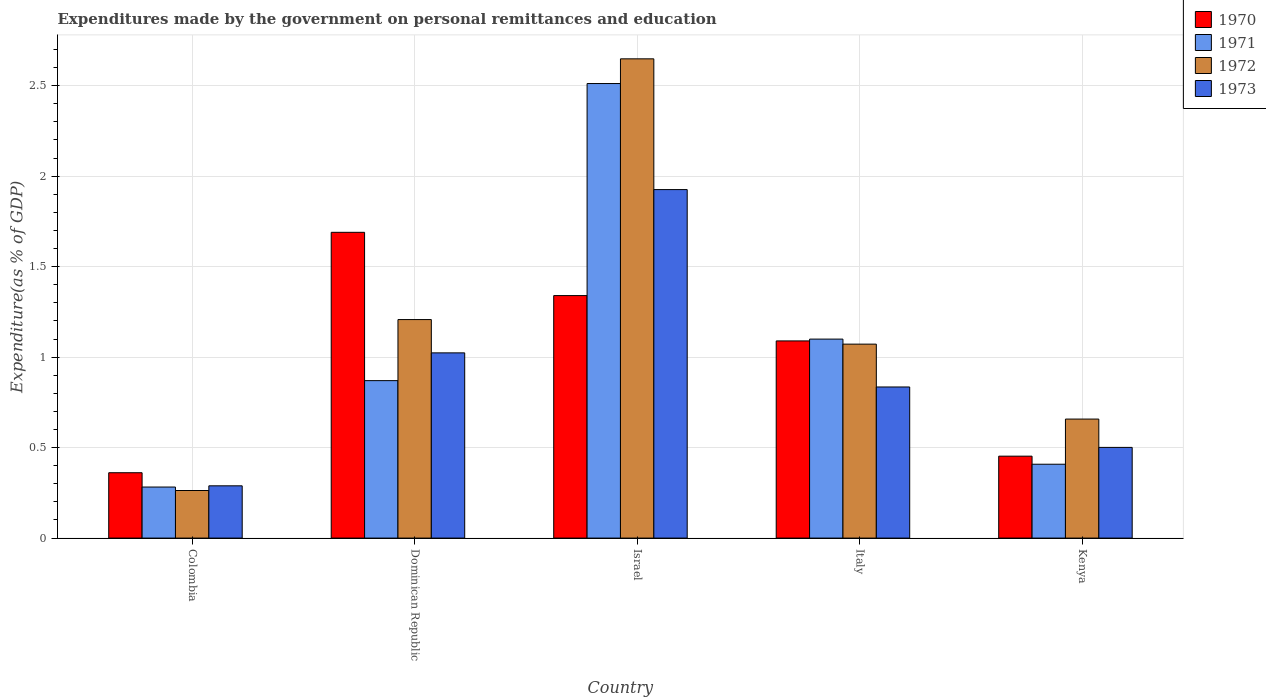How many groups of bars are there?
Offer a very short reply. 5. Are the number of bars on each tick of the X-axis equal?
Offer a terse response. Yes. What is the label of the 2nd group of bars from the left?
Ensure brevity in your answer.  Dominican Republic. What is the expenditures made by the government on personal remittances and education in 1972 in Colombia?
Your answer should be compact. 0.26. Across all countries, what is the maximum expenditures made by the government on personal remittances and education in 1972?
Ensure brevity in your answer.  2.65. Across all countries, what is the minimum expenditures made by the government on personal remittances and education in 1972?
Your answer should be very brief. 0.26. In which country was the expenditures made by the government on personal remittances and education in 1973 maximum?
Ensure brevity in your answer.  Israel. What is the total expenditures made by the government on personal remittances and education in 1970 in the graph?
Your answer should be compact. 4.93. What is the difference between the expenditures made by the government on personal remittances and education in 1973 in Colombia and that in Dominican Republic?
Keep it short and to the point. -0.73. What is the difference between the expenditures made by the government on personal remittances and education in 1972 in Italy and the expenditures made by the government on personal remittances and education in 1970 in Dominican Republic?
Make the answer very short. -0.62. What is the average expenditures made by the government on personal remittances and education in 1970 per country?
Make the answer very short. 0.99. What is the difference between the expenditures made by the government on personal remittances and education of/in 1970 and expenditures made by the government on personal remittances and education of/in 1973 in Italy?
Provide a succinct answer. 0.25. What is the ratio of the expenditures made by the government on personal remittances and education in 1973 in Colombia to that in Kenya?
Offer a terse response. 0.58. Is the expenditures made by the government on personal remittances and education in 1972 in Dominican Republic less than that in Italy?
Give a very brief answer. No. Is the difference between the expenditures made by the government on personal remittances and education in 1970 in Dominican Republic and Italy greater than the difference between the expenditures made by the government on personal remittances and education in 1973 in Dominican Republic and Italy?
Your answer should be compact. Yes. What is the difference between the highest and the second highest expenditures made by the government on personal remittances and education in 1973?
Your response must be concise. -1.09. What is the difference between the highest and the lowest expenditures made by the government on personal remittances and education in 1972?
Your response must be concise. 2.39. In how many countries, is the expenditures made by the government on personal remittances and education in 1970 greater than the average expenditures made by the government on personal remittances and education in 1970 taken over all countries?
Offer a very short reply. 3. Is the sum of the expenditures made by the government on personal remittances and education in 1972 in Dominican Republic and Israel greater than the maximum expenditures made by the government on personal remittances and education in 1970 across all countries?
Ensure brevity in your answer.  Yes. Is it the case that in every country, the sum of the expenditures made by the government on personal remittances and education in 1973 and expenditures made by the government on personal remittances and education in 1970 is greater than the sum of expenditures made by the government on personal remittances and education in 1972 and expenditures made by the government on personal remittances and education in 1971?
Ensure brevity in your answer.  No. Are all the bars in the graph horizontal?
Give a very brief answer. No. What is the difference between two consecutive major ticks on the Y-axis?
Provide a short and direct response. 0.5. Are the values on the major ticks of Y-axis written in scientific E-notation?
Your response must be concise. No. Where does the legend appear in the graph?
Make the answer very short. Top right. What is the title of the graph?
Offer a very short reply. Expenditures made by the government on personal remittances and education. What is the label or title of the Y-axis?
Provide a succinct answer. Expenditure(as % of GDP). What is the Expenditure(as % of GDP) in 1970 in Colombia?
Give a very brief answer. 0.36. What is the Expenditure(as % of GDP) of 1971 in Colombia?
Offer a terse response. 0.28. What is the Expenditure(as % of GDP) in 1972 in Colombia?
Your response must be concise. 0.26. What is the Expenditure(as % of GDP) in 1973 in Colombia?
Your response must be concise. 0.29. What is the Expenditure(as % of GDP) in 1970 in Dominican Republic?
Keep it short and to the point. 1.69. What is the Expenditure(as % of GDP) in 1971 in Dominican Republic?
Ensure brevity in your answer.  0.87. What is the Expenditure(as % of GDP) in 1972 in Dominican Republic?
Give a very brief answer. 1.21. What is the Expenditure(as % of GDP) in 1973 in Dominican Republic?
Give a very brief answer. 1.02. What is the Expenditure(as % of GDP) of 1970 in Israel?
Offer a very short reply. 1.34. What is the Expenditure(as % of GDP) of 1971 in Israel?
Offer a very short reply. 2.51. What is the Expenditure(as % of GDP) of 1972 in Israel?
Ensure brevity in your answer.  2.65. What is the Expenditure(as % of GDP) in 1973 in Israel?
Keep it short and to the point. 1.93. What is the Expenditure(as % of GDP) in 1970 in Italy?
Your response must be concise. 1.09. What is the Expenditure(as % of GDP) of 1971 in Italy?
Keep it short and to the point. 1.1. What is the Expenditure(as % of GDP) of 1972 in Italy?
Your answer should be compact. 1.07. What is the Expenditure(as % of GDP) in 1973 in Italy?
Provide a succinct answer. 0.84. What is the Expenditure(as % of GDP) of 1970 in Kenya?
Your response must be concise. 0.45. What is the Expenditure(as % of GDP) of 1971 in Kenya?
Ensure brevity in your answer.  0.41. What is the Expenditure(as % of GDP) of 1972 in Kenya?
Your answer should be compact. 0.66. What is the Expenditure(as % of GDP) of 1973 in Kenya?
Offer a terse response. 0.5. Across all countries, what is the maximum Expenditure(as % of GDP) of 1970?
Offer a very short reply. 1.69. Across all countries, what is the maximum Expenditure(as % of GDP) of 1971?
Your answer should be compact. 2.51. Across all countries, what is the maximum Expenditure(as % of GDP) of 1972?
Offer a very short reply. 2.65. Across all countries, what is the maximum Expenditure(as % of GDP) in 1973?
Provide a short and direct response. 1.93. Across all countries, what is the minimum Expenditure(as % of GDP) of 1970?
Offer a terse response. 0.36. Across all countries, what is the minimum Expenditure(as % of GDP) in 1971?
Offer a terse response. 0.28. Across all countries, what is the minimum Expenditure(as % of GDP) in 1972?
Provide a short and direct response. 0.26. Across all countries, what is the minimum Expenditure(as % of GDP) of 1973?
Give a very brief answer. 0.29. What is the total Expenditure(as % of GDP) of 1970 in the graph?
Give a very brief answer. 4.93. What is the total Expenditure(as % of GDP) in 1971 in the graph?
Make the answer very short. 5.17. What is the total Expenditure(as % of GDP) in 1972 in the graph?
Offer a very short reply. 5.85. What is the total Expenditure(as % of GDP) of 1973 in the graph?
Provide a short and direct response. 4.57. What is the difference between the Expenditure(as % of GDP) of 1970 in Colombia and that in Dominican Republic?
Provide a short and direct response. -1.33. What is the difference between the Expenditure(as % of GDP) of 1971 in Colombia and that in Dominican Republic?
Give a very brief answer. -0.59. What is the difference between the Expenditure(as % of GDP) of 1972 in Colombia and that in Dominican Republic?
Make the answer very short. -0.94. What is the difference between the Expenditure(as % of GDP) of 1973 in Colombia and that in Dominican Republic?
Your response must be concise. -0.73. What is the difference between the Expenditure(as % of GDP) of 1970 in Colombia and that in Israel?
Ensure brevity in your answer.  -0.98. What is the difference between the Expenditure(as % of GDP) of 1971 in Colombia and that in Israel?
Make the answer very short. -2.23. What is the difference between the Expenditure(as % of GDP) of 1972 in Colombia and that in Israel?
Give a very brief answer. -2.39. What is the difference between the Expenditure(as % of GDP) in 1973 in Colombia and that in Israel?
Your answer should be very brief. -1.64. What is the difference between the Expenditure(as % of GDP) of 1970 in Colombia and that in Italy?
Offer a very short reply. -0.73. What is the difference between the Expenditure(as % of GDP) of 1971 in Colombia and that in Italy?
Your answer should be very brief. -0.82. What is the difference between the Expenditure(as % of GDP) of 1972 in Colombia and that in Italy?
Give a very brief answer. -0.81. What is the difference between the Expenditure(as % of GDP) of 1973 in Colombia and that in Italy?
Offer a very short reply. -0.55. What is the difference between the Expenditure(as % of GDP) of 1970 in Colombia and that in Kenya?
Ensure brevity in your answer.  -0.09. What is the difference between the Expenditure(as % of GDP) in 1971 in Colombia and that in Kenya?
Provide a short and direct response. -0.13. What is the difference between the Expenditure(as % of GDP) of 1972 in Colombia and that in Kenya?
Provide a succinct answer. -0.39. What is the difference between the Expenditure(as % of GDP) in 1973 in Colombia and that in Kenya?
Your answer should be compact. -0.21. What is the difference between the Expenditure(as % of GDP) in 1970 in Dominican Republic and that in Israel?
Provide a succinct answer. 0.35. What is the difference between the Expenditure(as % of GDP) in 1971 in Dominican Republic and that in Israel?
Offer a very short reply. -1.64. What is the difference between the Expenditure(as % of GDP) of 1972 in Dominican Republic and that in Israel?
Offer a very short reply. -1.44. What is the difference between the Expenditure(as % of GDP) in 1973 in Dominican Republic and that in Israel?
Ensure brevity in your answer.  -0.9. What is the difference between the Expenditure(as % of GDP) of 1970 in Dominican Republic and that in Italy?
Give a very brief answer. 0.6. What is the difference between the Expenditure(as % of GDP) of 1971 in Dominican Republic and that in Italy?
Ensure brevity in your answer.  -0.23. What is the difference between the Expenditure(as % of GDP) of 1972 in Dominican Republic and that in Italy?
Your answer should be very brief. 0.14. What is the difference between the Expenditure(as % of GDP) in 1973 in Dominican Republic and that in Italy?
Make the answer very short. 0.19. What is the difference between the Expenditure(as % of GDP) in 1970 in Dominican Republic and that in Kenya?
Provide a succinct answer. 1.24. What is the difference between the Expenditure(as % of GDP) in 1971 in Dominican Republic and that in Kenya?
Keep it short and to the point. 0.46. What is the difference between the Expenditure(as % of GDP) of 1972 in Dominican Republic and that in Kenya?
Your response must be concise. 0.55. What is the difference between the Expenditure(as % of GDP) in 1973 in Dominican Republic and that in Kenya?
Keep it short and to the point. 0.52. What is the difference between the Expenditure(as % of GDP) in 1970 in Israel and that in Italy?
Keep it short and to the point. 0.25. What is the difference between the Expenditure(as % of GDP) in 1971 in Israel and that in Italy?
Provide a short and direct response. 1.41. What is the difference between the Expenditure(as % of GDP) in 1972 in Israel and that in Italy?
Keep it short and to the point. 1.58. What is the difference between the Expenditure(as % of GDP) of 1973 in Israel and that in Italy?
Give a very brief answer. 1.09. What is the difference between the Expenditure(as % of GDP) of 1970 in Israel and that in Kenya?
Keep it short and to the point. 0.89. What is the difference between the Expenditure(as % of GDP) of 1971 in Israel and that in Kenya?
Provide a succinct answer. 2.1. What is the difference between the Expenditure(as % of GDP) in 1972 in Israel and that in Kenya?
Keep it short and to the point. 1.99. What is the difference between the Expenditure(as % of GDP) of 1973 in Israel and that in Kenya?
Your answer should be compact. 1.42. What is the difference between the Expenditure(as % of GDP) of 1970 in Italy and that in Kenya?
Make the answer very short. 0.64. What is the difference between the Expenditure(as % of GDP) of 1971 in Italy and that in Kenya?
Keep it short and to the point. 0.69. What is the difference between the Expenditure(as % of GDP) of 1972 in Italy and that in Kenya?
Your answer should be compact. 0.41. What is the difference between the Expenditure(as % of GDP) in 1973 in Italy and that in Kenya?
Provide a succinct answer. 0.33. What is the difference between the Expenditure(as % of GDP) in 1970 in Colombia and the Expenditure(as % of GDP) in 1971 in Dominican Republic?
Offer a very short reply. -0.51. What is the difference between the Expenditure(as % of GDP) of 1970 in Colombia and the Expenditure(as % of GDP) of 1972 in Dominican Republic?
Give a very brief answer. -0.85. What is the difference between the Expenditure(as % of GDP) of 1970 in Colombia and the Expenditure(as % of GDP) of 1973 in Dominican Republic?
Keep it short and to the point. -0.66. What is the difference between the Expenditure(as % of GDP) in 1971 in Colombia and the Expenditure(as % of GDP) in 1972 in Dominican Republic?
Provide a short and direct response. -0.93. What is the difference between the Expenditure(as % of GDP) of 1971 in Colombia and the Expenditure(as % of GDP) of 1973 in Dominican Republic?
Your answer should be compact. -0.74. What is the difference between the Expenditure(as % of GDP) in 1972 in Colombia and the Expenditure(as % of GDP) in 1973 in Dominican Republic?
Your answer should be very brief. -0.76. What is the difference between the Expenditure(as % of GDP) of 1970 in Colombia and the Expenditure(as % of GDP) of 1971 in Israel?
Your answer should be very brief. -2.15. What is the difference between the Expenditure(as % of GDP) of 1970 in Colombia and the Expenditure(as % of GDP) of 1972 in Israel?
Offer a terse response. -2.29. What is the difference between the Expenditure(as % of GDP) in 1970 in Colombia and the Expenditure(as % of GDP) in 1973 in Israel?
Provide a short and direct response. -1.56. What is the difference between the Expenditure(as % of GDP) of 1971 in Colombia and the Expenditure(as % of GDP) of 1972 in Israel?
Your answer should be compact. -2.37. What is the difference between the Expenditure(as % of GDP) in 1971 in Colombia and the Expenditure(as % of GDP) in 1973 in Israel?
Your answer should be very brief. -1.64. What is the difference between the Expenditure(as % of GDP) in 1972 in Colombia and the Expenditure(as % of GDP) in 1973 in Israel?
Provide a short and direct response. -1.66. What is the difference between the Expenditure(as % of GDP) of 1970 in Colombia and the Expenditure(as % of GDP) of 1971 in Italy?
Offer a terse response. -0.74. What is the difference between the Expenditure(as % of GDP) of 1970 in Colombia and the Expenditure(as % of GDP) of 1972 in Italy?
Make the answer very short. -0.71. What is the difference between the Expenditure(as % of GDP) in 1970 in Colombia and the Expenditure(as % of GDP) in 1973 in Italy?
Offer a very short reply. -0.47. What is the difference between the Expenditure(as % of GDP) in 1971 in Colombia and the Expenditure(as % of GDP) in 1972 in Italy?
Provide a succinct answer. -0.79. What is the difference between the Expenditure(as % of GDP) of 1971 in Colombia and the Expenditure(as % of GDP) of 1973 in Italy?
Give a very brief answer. -0.55. What is the difference between the Expenditure(as % of GDP) of 1972 in Colombia and the Expenditure(as % of GDP) of 1973 in Italy?
Offer a very short reply. -0.57. What is the difference between the Expenditure(as % of GDP) in 1970 in Colombia and the Expenditure(as % of GDP) in 1971 in Kenya?
Keep it short and to the point. -0.05. What is the difference between the Expenditure(as % of GDP) of 1970 in Colombia and the Expenditure(as % of GDP) of 1972 in Kenya?
Provide a succinct answer. -0.3. What is the difference between the Expenditure(as % of GDP) in 1970 in Colombia and the Expenditure(as % of GDP) in 1973 in Kenya?
Your answer should be very brief. -0.14. What is the difference between the Expenditure(as % of GDP) of 1971 in Colombia and the Expenditure(as % of GDP) of 1972 in Kenya?
Give a very brief answer. -0.38. What is the difference between the Expenditure(as % of GDP) in 1971 in Colombia and the Expenditure(as % of GDP) in 1973 in Kenya?
Keep it short and to the point. -0.22. What is the difference between the Expenditure(as % of GDP) of 1972 in Colombia and the Expenditure(as % of GDP) of 1973 in Kenya?
Give a very brief answer. -0.24. What is the difference between the Expenditure(as % of GDP) of 1970 in Dominican Republic and the Expenditure(as % of GDP) of 1971 in Israel?
Provide a succinct answer. -0.82. What is the difference between the Expenditure(as % of GDP) of 1970 in Dominican Republic and the Expenditure(as % of GDP) of 1972 in Israel?
Give a very brief answer. -0.96. What is the difference between the Expenditure(as % of GDP) in 1970 in Dominican Republic and the Expenditure(as % of GDP) in 1973 in Israel?
Provide a succinct answer. -0.24. What is the difference between the Expenditure(as % of GDP) in 1971 in Dominican Republic and the Expenditure(as % of GDP) in 1972 in Israel?
Ensure brevity in your answer.  -1.78. What is the difference between the Expenditure(as % of GDP) of 1971 in Dominican Republic and the Expenditure(as % of GDP) of 1973 in Israel?
Provide a succinct answer. -1.06. What is the difference between the Expenditure(as % of GDP) in 1972 in Dominican Republic and the Expenditure(as % of GDP) in 1973 in Israel?
Provide a succinct answer. -0.72. What is the difference between the Expenditure(as % of GDP) of 1970 in Dominican Republic and the Expenditure(as % of GDP) of 1971 in Italy?
Keep it short and to the point. 0.59. What is the difference between the Expenditure(as % of GDP) in 1970 in Dominican Republic and the Expenditure(as % of GDP) in 1972 in Italy?
Your answer should be compact. 0.62. What is the difference between the Expenditure(as % of GDP) of 1970 in Dominican Republic and the Expenditure(as % of GDP) of 1973 in Italy?
Offer a terse response. 0.85. What is the difference between the Expenditure(as % of GDP) in 1971 in Dominican Republic and the Expenditure(as % of GDP) in 1972 in Italy?
Provide a short and direct response. -0.2. What is the difference between the Expenditure(as % of GDP) in 1971 in Dominican Republic and the Expenditure(as % of GDP) in 1973 in Italy?
Your response must be concise. 0.04. What is the difference between the Expenditure(as % of GDP) of 1972 in Dominican Republic and the Expenditure(as % of GDP) of 1973 in Italy?
Give a very brief answer. 0.37. What is the difference between the Expenditure(as % of GDP) in 1970 in Dominican Republic and the Expenditure(as % of GDP) in 1971 in Kenya?
Provide a short and direct response. 1.28. What is the difference between the Expenditure(as % of GDP) of 1970 in Dominican Republic and the Expenditure(as % of GDP) of 1972 in Kenya?
Keep it short and to the point. 1.03. What is the difference between the Expenditure(as % of GDP) of 1970 in Dominican Republic and the Expenditure(as % of GDP) of 1973 in Kenya?
Keep it short and to the point. 1.19. What is the difference between the Expenditure(as % of GDP) in 1971 in Dominican Republic and the Expenditure(as % of GDP) in 1972 in Kenya?
Keep it short and to the point. 0.21. What is the difference between the Expenditure(as % of GDP) of 1971 in Dominican Republic and the Expenditure(as % of GDP) of 1973 in Kenya?
Make the answer very short. 0.37. What is the difference between the Expenditure(as % of GDP) in 1972 in Dominican Republic and the Expenditure(as % of GDP) in 1973 in Kenya?
Give a very brief answer. 0.71. What is the difference between the Expenditure(as % of GDP) in 1970 in Israel and the Expenditure(as % of GDP) in 1971 in Italy?
Make the answer very short. 0.24. What is the difference between the Expenditure(as % of GDP) of 1970 in Israel and the Expenditure(as % of GDP) of 1972 in Italy?
Provide a short and direct response. 0.27. What is the difference between the Expenditure(as % of GDP) of 1970 in Israel and the Expenditure(as % of GDP) of 1973 in Italy?
Offer a terse response. 0.51. What is the difference between the Expenditure(as % of GDP) in 1971 in Israel and the Expenditure(as % of GDP) in 1972 in Italy?
Provide a short and direct response. 1.44. What is the difference between the Expenditure(as % of GDP) of 1971 in Israel and the Expenditure(as % of GDP) of 1973 in Italy?
Keep it short and to the point. 1.68. What is the difference between the Expenditure(as % of GDP) of 1972 in Israel and the Expenditure(as % of GDP) of 1973 in Italy?
Provide a succinct answer. 1.81. What is the difference between the Expenditure(as % of GDP) in 1970 in Israel and the Expenditure(as % of GDP) in 1971 in Kenya?
Make the answer very short. 0.93. What is the difference between the Expenditure(as % of GDP) in 1970 in Israel and the Expenditure(as % of GDP) in 1972 in Kenya?
Keep it short and to the point. 0.68. What is the difference between the Expenditure(as % of GDP) of 1970 in Israel and the Expenditure(as % of GDP) of 1973 in Kenya?
Your response must be concise. 0.84. What is the difference between the Expenditure(as % of GDP) in 1971 in Israel and the Expenditure(as % of GDP) in 1972 in Kenya?
Ensure brevity in your answer.  1.85. What is the difference between the Expenditure(as % of GDP) in 1971 in Israel and the Expenditure(as % of GDP) in 1973 in Kenya?
Ensure brevity in your answer.  2.01. What is the difference between the Expenditure(as % of GDP) in 1972 in Israel and the Expenditure(as % of GDP) in 1973 in Kenya?
Offer a terse response. 2.15. What is the difference between the Expenditure(as % of GDP) in 1970 in Italy and the Expenditure(as % of GDP) in 1971 in Kenya?
Your response must be concise. 0.68. What is the difference between the Expenditure(as % of GDP) of 1970 in Italy and the Expenditure(as % of GDP) of 1972 in Kenya?
Your answer should be very brief. 0.43. What is the difference between the Expenditure(as % of GDP) of 1970 in Italy and the Expenditure(as % of GDP) of 1973 in Kenya?
Provide a short and direct response. 0.59. What is the difference between the Expenditure(as % of GDP) in 1971 in Italy and the Expenditure(as % of GDP) in 1972 in Kenya?
Make the answer very short. 0.44. What is the difference between the Expenditure(as % of GDP) of 1971 in Italy and the Expenditure(as % of GDP) of 1973 in Kenya?
Ensure brevity in your answer.  0.6. What is the difference between the Expenditure(as % of GDP) in 1972 in Italy and the Expenditure(as % of GDP) in 1973 in Kenya?
Your answer should be compact. 0.57. What is the average Expenditure(as % of GDP) in 1970 per country?
Offer a terse response. 0.99. What is the average Expenditure(as % of GDP) in 1971 per country?
Your answer should be very brief. 1.03. What is the average Expenditure(as % of GDP) of 1972 per country?
Ensure brevity in your answer.  1.17. What is the average Expenditure(as % of GDP) of 1973 per country?
Provide a short and direct response. 0.91. What is the difference between the Expenditure(as % of GDP) in 1970 and Expenditure(as % of GDP) in 1971 in Colombia?
Ensure brevity in your answer.  0.08. What is the difference between the Expenditure(as % of GDP) in 1970 and Expenditure(as % of GDP) in 1972 in Colombia?
Keep it short and to the point. 0.1. What is the difference between the Expenditure(as % of GDP) in 1970 and Expenditure(as % of GDP) in 1973 in Colombia?
Ensure brevity in your answer.  0.07. What is the difference between the Expenditure(as % of GDP) in 1971 and Expenditure(as % of GDP) in 1972 in Colombia?
Ensure brevity in your answer.  0.02. What is the difference between the Expenditure(as % of GDP) of 1971 and Expenditure(as % of GDP) of 1973 in Colombia?
Your answer should be compact. -0.01. What is the difference between the Expenditure(as % of GDP) of 1972 and Expenditure(as % of GDP) of 1973 in Colombia?
Ensure brevity in your answer.  -0.03. What is the difference between the Expenditure(as % of GDP) in 1970 and Expenditure(as % of GDP) in 1971 in Dominican Republic?
Offer a very short reply. 0.82. What is the difference between the Expenditure(as % of GDP) in 1970 and Expenditure(as % of GDP) in 1972 in Dominican Republic?
Make the answer very short. 0.48. What is the difference between the Expenditure(as % of GDP) of 1970 and Expenditure(as % of GDP) of 1973 in Dominican Republic?
Offer a very short reply. 0.67. What is the difference between the Expenditure(as % of GDP) of 1971 and Expenditure(as % of GDP) of 1972 in Dominican Republic?
Give a very brief answer. -0.34. What is the difference between the Expenditure(as % of GDP) in 1971 and Expenditure(as % of GDP) in 1973 in Dominican Republic?
Provide a short and direct response. -0.15. What is the difference between the Expenditure(as % of GDP) in 1972 and Expenditure(as % of GDP) in 1973 in Dominican Republic?
Ensure brevity in your answer.  0.18. What is the difference between the Expenditure(as % of GDP) in 1970 and Expenditure(as % of GDP) in 1971 in Israel?
Your response must be concise. -1.17. What is the difference between the Expenditure(as % of GDP) of 1970 and Expenditure(as % of GDP) of 1972 in Israel?
Provide a succinct answer. -1.31. What is the difference between the Expenditure(as % of GDP) in 1970 and Expenditure(as % of GDP) in 1973 in Israel?
Your answer should be compact. -0.59. What is the difference between the Expenditure(as % of GDP) in 1971 and Expenditure(as % of GDP) in 1972 in Israel?
Your response must be concise. -0.14. What is the difference between the Expenditure(as % of GDP) in 1971 and Expenditure(as % of GDP) in 1973 in Israel?
Your response must be concise. 0.59. What is the difference between the Expenditure(as % of GDP) of 1972 and Expenditure(as % of GDP) of 1973 in Israel?
Make the answer very short. 0.72. What is the difference between the Expenditure(as % of GDP) of 1970 and Expenditure(as % of GDP) of 1971 in Italy?
Ensure brevity in your answer.  -0.01. What is the difference between the Expenditure(as % of GDP) in 1970 and Expenditure(as % of GDP) in 1972 in Italy?
Provide a succinct answer. 0.02. What is the difference between the Expenditure(as % of GDP) in 1970 and Expenditure(as % of GDP) in 1973 in Italy?
Ensure brevity in your answer.  0.25. What is the difference between the Expenditure(as % of GDP) of 1971 and Expenditure(as % of GDP) of 1972 in Italy?
Your response must be concise. 0.03. What is the difference between the Expenditure(as % of GDP) in 1971 and Expenditure(as % of GDP) in 1973 in Italy?
Provide a short and direct response. 0.26. What is the difference between the Expenditure(as % of GDP) in 1972 and Expenditure(as % of GDP) in 1973 in Italy?
Your answer should be compact. 0.24. What is the difference between the Expenditure(as % of GDP) in 1970 and Expenditure(as % of GDP) in 1971 in Kenya?
Your response must be concise. 0.04. What is the difference between the Expenditure(as % of GDP) of 1970 and Expenditure(as % of GDP) of 1972 in Kenya?
Offer a terse response. -0.2. What is the difference between the Expenditure(as % of GDP) in 1970 and Expenditure(as % of GDP) in 1973 in Kenya?
Provide a short and direct response. -0.05. What is the difference between the Expenditure(as % of GDP) of 1971 and Expenditure(as % of GDP) of 1972 in Kenya?
Make the answer very short. -0.25. What is the difference between the Expenditure(as % of GDP) in 1971 and Expenditure(as % of GDP) in 1973 in Kenya?
Make the answer very short. -0.09. What is the difference between the Expenditure(as % of GDP) of 1972 and Expenditure(as % of GDP) of 1973 in Kenya?
Your answer should be very brief. 0.16. What is the ratio of the Expenditure(as % of GDP) in 1970 in Colombia to that in Dominican Republic?
Ensure brevity in your answer.  0.21. What is the ratio of the Expenditure(as % of GDP) in 1971 in Colombia to that in Dominican Republic?
Keep it short and to the point. 0.32. What is the ratio of the Expenditure(as % of GDP) of 1972 in Colombia to that in Dominican Republic?
Give a very brief answer. 0.22. What is the ratio of the Expenditure(as % of GDP) in 1973 in Colombia to that in Dominican Republic?
Provide a succinct answer. 0.28. What is the ratio of the Expenditure(as % of GDP) of 1970 in Colombia to that in Israel?
Offer a terse response. 0.27. What is the ratio of the Expenditure(as % of GDP) in 1971 in Colombia to that in Israel?
Offer a very short reply. 0.11. What is the ratio of the Expenditure(as % of GDP) in 1972 in Colombia to that in Israel?
Ensure brevity in your answer.  0.1. What is the ratio of the Expenditure(as % of GDP) in 1970 in Colombia to that in Italy?
Provide a short and direct response. 0.33. What is the ratio of the Expenditure(as % of GDP) of 1971 in Colombia to that in Italy?
Provide a succinct answer. 0.26. What is the ratio of the Expenditure(as % of GDP) of 1972 in Colombia to that in Italy?
Make the answer very short. 0.25. What is the ratio of the Expenditure(as % of GDP) in 1973 in Colombia to that in Italy?
Make the answer very short. 0.35. What is the ratio of the Expenditure(as % of GDP) in 1970 in Colombia to that in Kenya?
Provide a succinct answer. 0.8. What is the ratio of the Expenditure(as % of GDP) in 1971 in Colombia to that in Kenya?
Your answer should be compact. 0.69. What is the ratio of the Expenditure(as % of GDP) in 1972 in Colombia to that in Kenya?
Give a very brief answer. 0.4. What is the ratio of the Expenditure(as % of GDP) of 1973 in Colombia to that in Kenya?
Provide a short and direct response. 0.58. What is the ratio of the Expenditure(as % of GDP) in 1970 in Dominican Republic to that in Israel?
Your response must be concise. 1.26. What is the ratio of the Expenditure(as % of GDP) in 1971 in Dominican Republic to that in Israel?
Offer a very short reply. 0.35. What is the ratio of the Expenditure(as % of GDP) of 1972 in Dominican Republic to that in Israel?
Ensure brevity in your answer.  0.46. What is the ratio of the Expenditure(as % of GDP) of 1973 in Dominican Republic to that in Israel?
Your answer should be very brief. 0.53. What is the ratio of the Expenditure(as % of GDP) in 1970 in Dominican Republic to that in Italy?
Provide a succinct answer. 1.55. What is the ratio of the Expenditure(as % of GDP) of 1971 in Dominican Republic to that in Italy?
Give a very brief answer. 0.79. What is the ratio of the Expenditure(as % of GDP) in 1972 in Dominican Republic to that in Italy?
Offer a terse response. 1.13. What is the ratio of the Expenditure(as % of GDP) of 1973 in Dominican Republic to that in Italy?
Your answer should be compact. 1.23. What is the ratio of the Expenditure(as % of GDP) in 1970 in Dominican Republic to that in Kenya?
Your response must be concise. 3.73. What is the ratio of the Expenditure(as % of GDP) of 1971 in Dominican Republic to that in Kenya?
Offer a terse response. 2.13. What is the ratio of the Expenditure(as % of GDP) in 1972 in Dominican Republic to that in Kenya?
Provide a succinct answer. 1.84. What is the ratio of the Expenditure(as % of GDP) of 1973 in Dominican Republic to that in Kenya?
Your answer should be very brief. 2.04. What is the ratio of the Expenditure(as % of GDP) of 1970 in Israel to that in Italy?
Keep it short and to the point. 1.23. What is the ratio of the Expenditure(as % of GDP) in 1971 in Israel to that in Italy?
Provide a short and direct response. 2.28. What is the ratio of the Expenditure(as % of GDP) of 1972 in Israel to that in Italy?
Make the answer very short. 2.47. What is the ratio of the Expenditure(as % of GDP) of 1973 in Israel to that in Italy?
Offer a very short reply. 2.31. What is the ratio of the Expenditure(as % of GDP) of 1970 in Israel to that in Kenya?
Provide a short and direct response. 2.96. What is the ratio of the Expenditure(as % of GDP) in 1971 in Israel to that in Kenya?
Provide a succinct answer. 6.15. What is the ratio of the Expenditure(as % of GDP) in 1972 in Israel to that in Kenya?
Offer a very short reply. 4.03. What is the ratio of the Expenditure(as % of GDP) in 1973 in Israel to that in Kenya?
Make the answer very short. 3.84. What is the ratio of the Expenditure(as % of GDP) of 1970 in Italy to that in Kenya?
Offer a terse response. 2.41. What is the ratio of the Expenditure(as % of GDP) of 1971 in Italy to that in Kenya?
Offer a very short reply. 2.69. What is the ratio of the Expenditure(as % of GDP) of 1972 in Italy to that in Kenya?
Ensure brevity in your answer.  1.63. What is the ratio of the Expenditure(as % of GDP) of 1973 in Italy to that in Kenya?
Your response must be concise. 1.67. What is the difference between the highest and the second highest Expenditure(as % of GDP) of 1970?
Provide a short and direct response. 0.35. What is the difference between the highest and the second highest Expenditure(as % of GDP) of 1971?
Give a very brief answer. 1.41. What is the difference between the highest and the second highest Expenditure(as % of GDP) in 1972?
Your answer should be compact. 1.44. What is the difference between the highest and the second highest Expenditure(as % of GDP) of 1973?
Your response must be concise. 0.9. What is the difference between the highest and the lowest Expenditure(as % of GDP) of 1970?
Offer a very short reply. 1.33. What is the difference between the highest and the lowest Expenditure(as % of GDP) of 1971?
Make the answer very short. 2.23. What is the difference between the highest and the lowest Expenditure(as % of GDP) of 1972?
Keep it short and to the point. 2.39. What is the difference between the highest and the lowest Expenditure(as % of GDP) of 1973?
Your answer should be very brief. 1.64. 